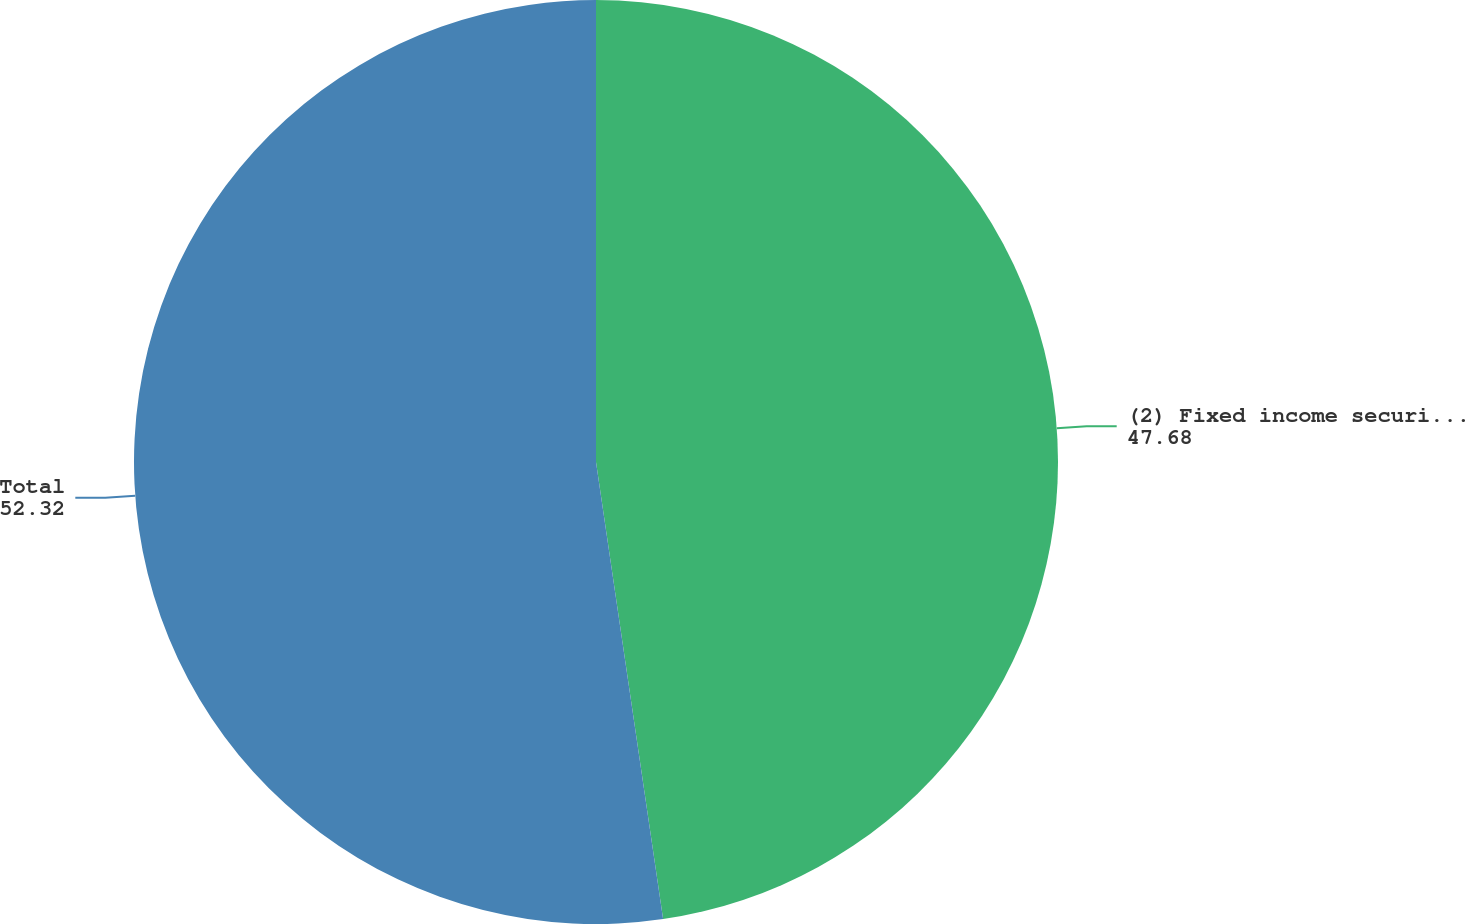Convert chart. <chart><loc_0><loc_0><loc_500><loc_500><pie_chart><fcel>(2) Fixed income securities<fcel>Total<nl><fcel>47.68%<fcel>52.32%<nl></chart> 